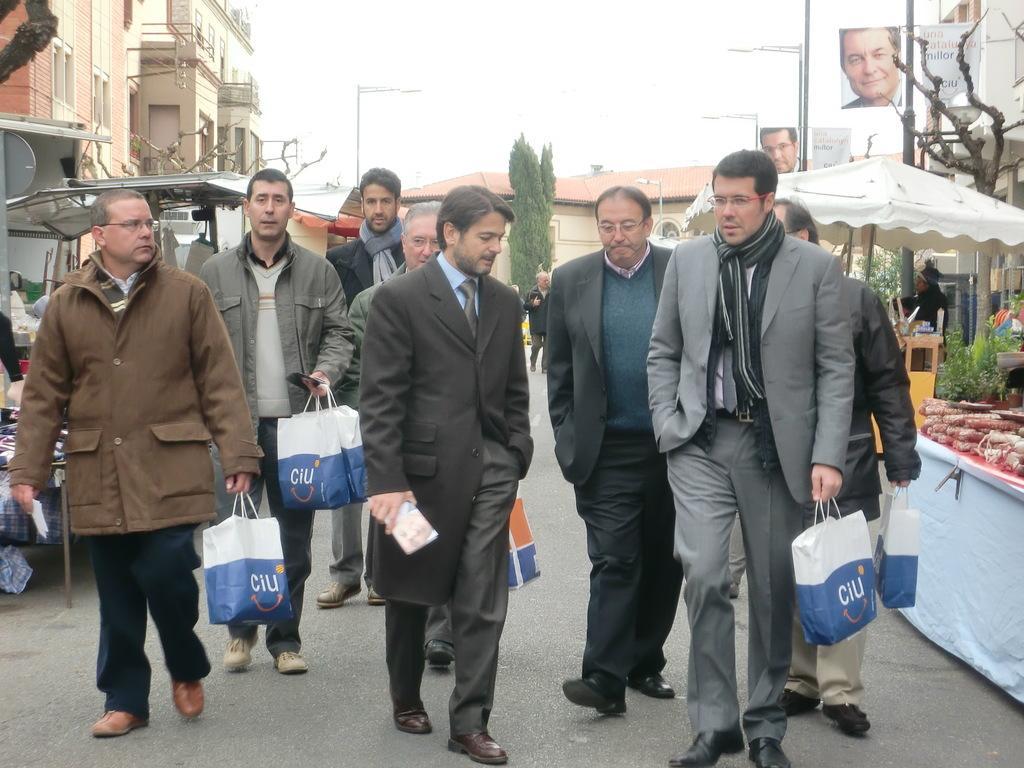In one or two sentences, can you explain what this image depicts? In this image we can see a group of persons and among them few persons are holding objects. Behind the persons we can see buildings, trees and stalls. On the right side, we can see plants and few objects on a table. A cloth is attached to the table. At the top we can see the sky and poles with banners. On the banners we can see the images and text. 